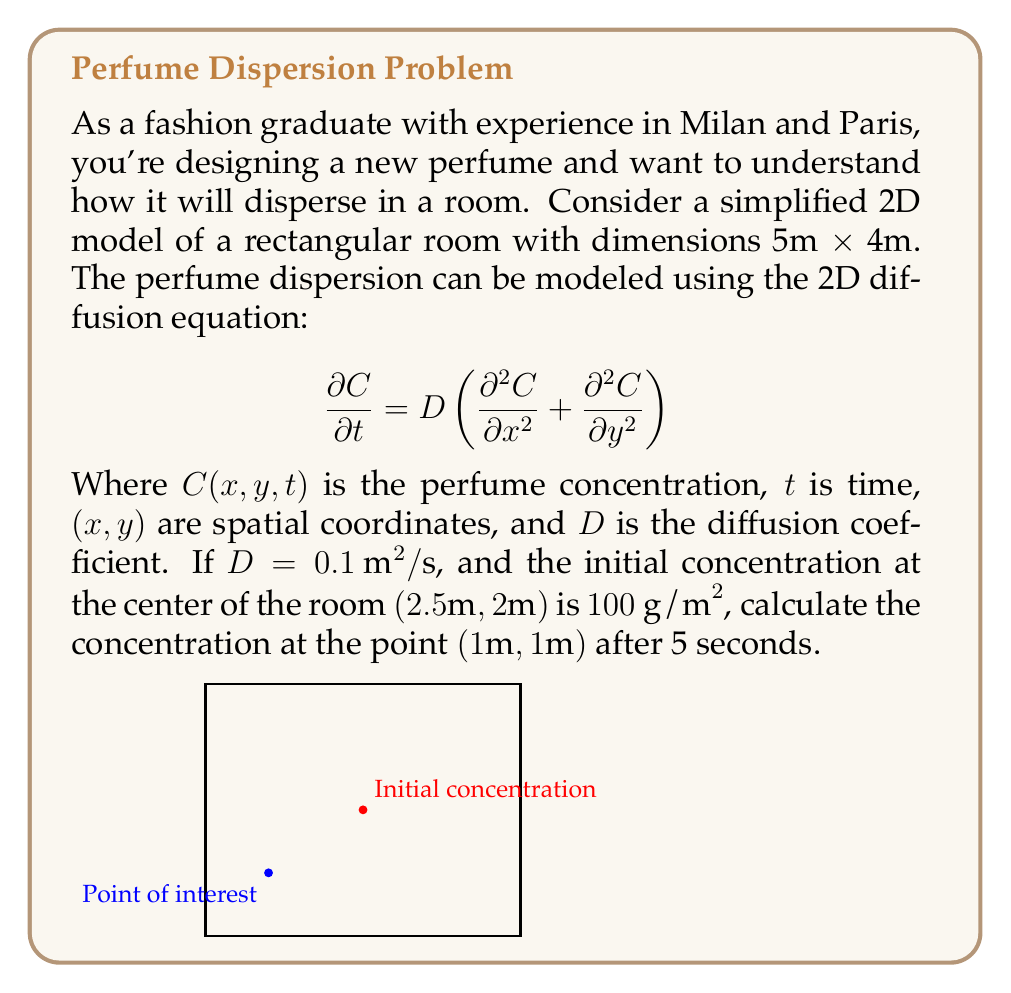Can you solve this math problem? To solve this problem, we can use the 2D diffusion equation solution for an instantaneous point source in an infinite domain:

$$C(x,y,t) = \frac{M}{4\pi Dt} \exp\left(-\frac{(x-x_0)^2 + (y-y_0)^2}{4Dt}\right)$$

Where:
- $M$ is the total mass released (initial concentration × area)
- $(x_0, y_0)$ is the initial release point
- $D$ is the diffusion coefficient
- $t$ is time

Step 1: Calculate the total mass released
$M = 100 \text{ g/m}^2 \times (1\text{ m}^2) = 100 \text{ g}$

Step 2: Plug in the values
- $D = 0.1 \text{ m}^2/\text{s}$
- $t = 5 \text{ s}$
- $(x_0, y_0) = (2.5\text{ m}, 2\text{ m})$
- $(x, y) = (1\text{ m}, 1\text{ m})$

$$C(1,1,5) = \frac{100}{4\pi (0.1)(5)} \exp\left(-\frac{(1-2.5)^2 + (1-2)^2}{4(0.1)(5)}\right)$$

Step 3: Simplify and calculate
$$C(1,1,5) = \frac{100}{2\pi} \exp\left(-\frac{2.25 + 1}{2}\right) \approx 1.77 \text{ g/m}^2$$
Answer: $1.77 \text{ g/m}^2$ 